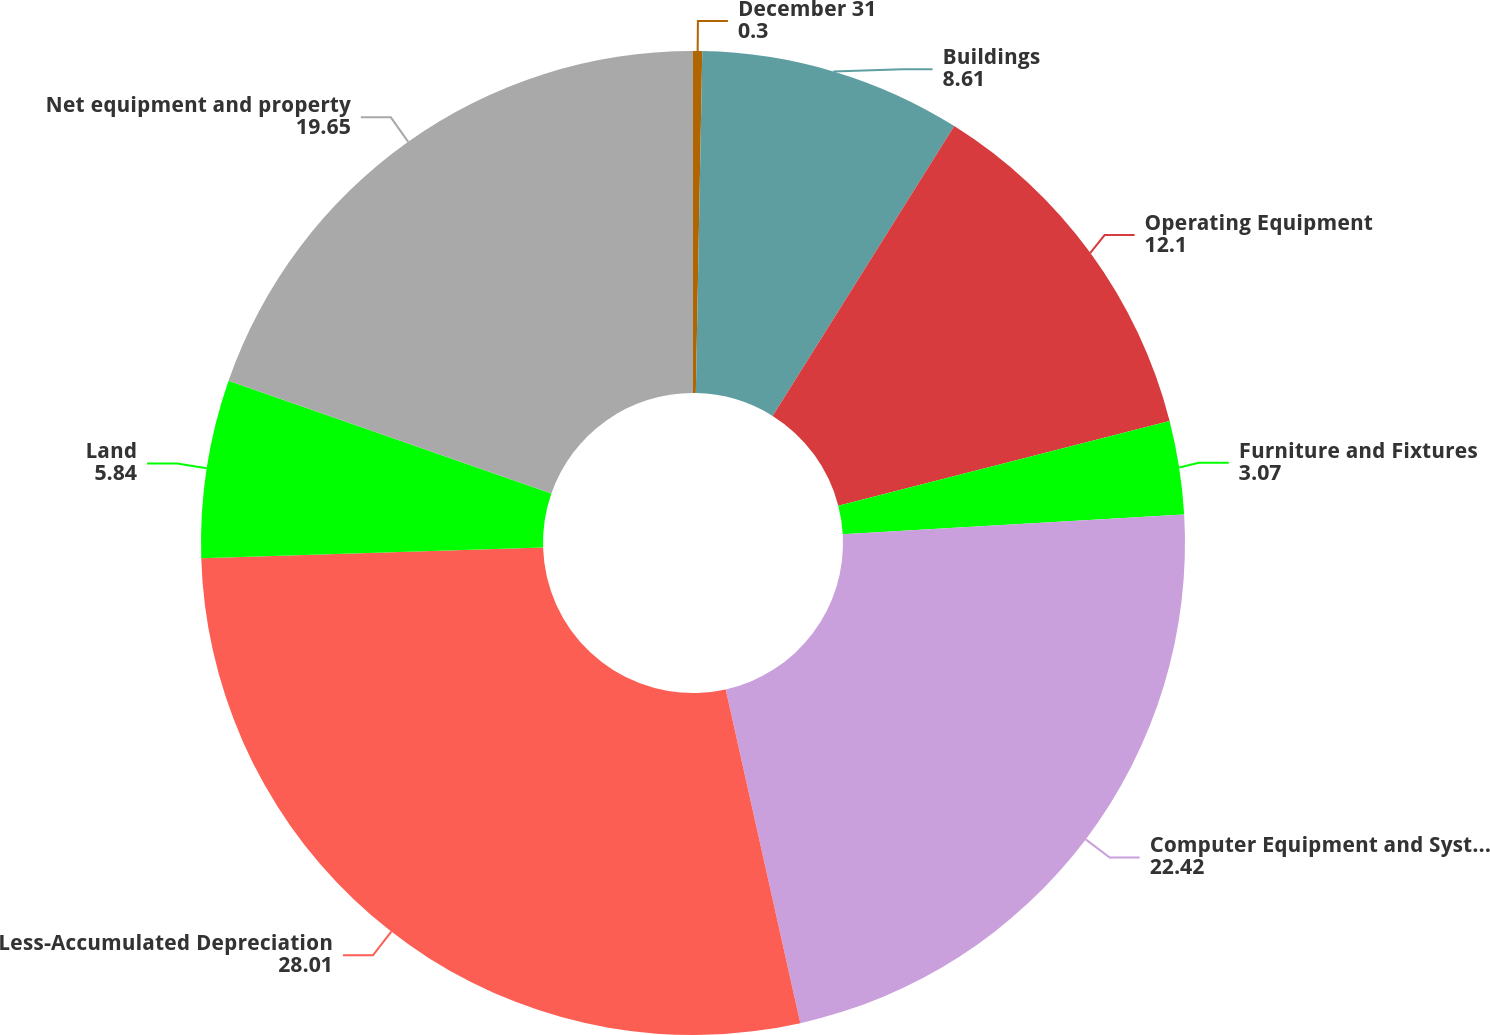<chart> <loc_0><loc_0><loc_500><loc_500><pie_chart><fcel>December 31<fcel>Buildings<fcel>Operating Equipment<fcel>Furniture and Fixtures<fcel>Computer Equipment and Systems<fcel>Less-Accumulated Depreciation<fcel>Land<fcel>Net equipment and property<nl><fcel>0.3%<fcel>8.61%<fcel>12.1%<fcel>3.07%<fcel>22.42%<fcel>28.01%<fcel>5.84%<fcel>19.65%<nl></chart> 